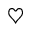<formula> <loc_0><loc_0><loc_500><loc_500>\heartsuit</formula> 